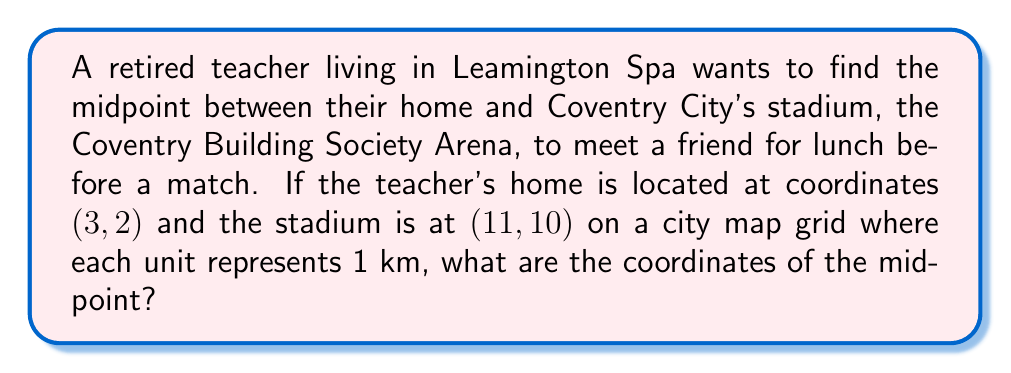Show me your answer to this math problem. To find the midpoint between two points in a coordinate system, we use the midpoint formula:

$$\text{Midpoint} = \left(\frac{x_1 + x_2}{2}, \frac{y_1 + y_2}{2}\right)$$

Where $(x_1, y_1)$ is the first point and $(x_2, y_2)$ is the second point.

In this case:
- The teacher's home is at $(x_1, y_1) = (3, 2)$
- The stadium is at $(x_2, y_2) = (11, 10)$

Let's plug these values into the midpoint formula:

$$\text{Midpoint} = \left(\frac{3 + 11}{2}, \frac{2 + 10}{2}\right)$$

Simplifying:

$$\text{Midpoint} = \left(\frac{14}{2}, \frac{12}{2}\right)$$

$$\text{Midpoint} = (7, 6)$$

Therefore, the midpoint between the teacher's home and the Coventry Building Society Arena is at coordinates (7, 6) on the city map grid.

[asy]
unitsize(0.5cm);
defaultpen(fontsize(10pt));

// Draw grid
for(int i = 0; i <= 12; ++i) {
  draw((i,0)--(i,12), gray+opacity(0.5));
  draw((0,i)--(12,i), gray+opacity(0.5));
}

// Label axes
label("x", (12,0), E);
label("y", (0,12), N);

// Plot points and midpoint
dot((3,2), red);
dot((11,10), blue);
dot((7,6), green);

label("Home (3, 2)", (3,2), SW, red);
label("Stadium (11, 10)", (11,10), NE, blue);
label("Midpoint (7, 6)", (7,6), SE, green);

// Draw line connecting points
draw((3,2)--(11,10), dashed);
[/asy]
Answer: The coordinates of the midpoint are (7, 6). 